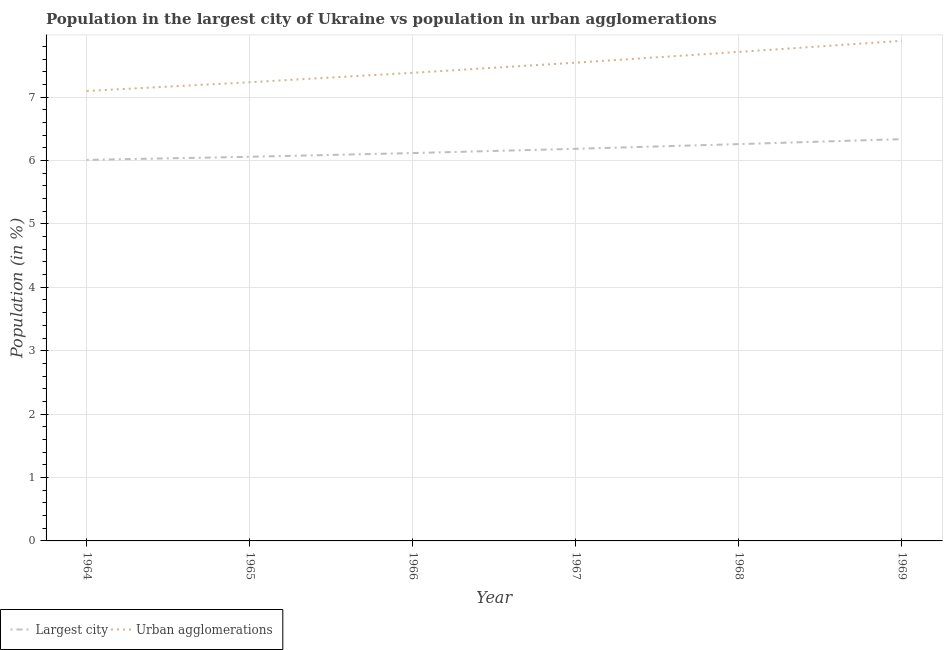How many different coloured lines are there?
Provide a short and direct response. 2. Is the number of lines equal to the number of legend labels?
Your response must be concise. Yes. What is the population in the largest city in 1968?
Your answer should be compact. 6.26. Across all years, what is the maximum population in the largest city?
Offer a very short reply. 6.34. Across all years, what is the minimum population in urban agglomerations?
Your answer should be compact. 7.1. In which year was the population in the largest city maximum?
Make the answer very short. 1969. In which year was the population in urban agglomerations minimum?
Provide a succinct answer. 1964. What is the total population in the largest city in the graph?
Provide a short and direct response. 36.96. What is the difference between the population in urban agglomerations in 1965 and that in 1968?
Provide a short and direct response. -0.48. What is the difference between the population in urban agglomerations in 1966 and the population in the largest city in 1964?
Keep it short and to the point. 1.37. What is the average population in the largest city per year?
Offer a terse response. 6.16. In the year 1964, what is the difference between the population in the largest city and population in urban agglomerations?
Offer a terse response. -1.09. What is the ratio of the population in the largest city in 1966 to that in 1968?
Provide a succinct answer. 0.98. Is the population in urban agglomerations in 1964 less than that in 1967?
Give a very brief answer. Yes. Is the difference between the population in urban agglomerations in 1966 and 1968 greater than the difference between the population in the largest city in 1966 and 1968?
Your response must be concise. No. What is the difference between the highest and the second highest population in the largest city?
Make the answer very short. 0.08. What is the difference between the highest and the lowest population in urban agglomerations?
Give a very brief answer. 0.79. In how many years, is the population in the largest city greater than the average population in the largest city taken over all years?
Provide a succinct answer. 3. Is the population in the largest city strictly greater than the population in urban agglomerations over the years?
Your answer should be very brief. No. How many lines are there?
Offer a terse response. 2. Are the values on the major ticks of Y-axis written in scientific E-notation?
Your answer should be very brief. No. Does the graph contain grids?
Provide a succinct answer. Yes. Where does the legend appear in the graph?
Offer a terse response. Bottom left. How many legend labels are there?
Make the answer very short. 2. What is the title of the graph?
Your answer should be very brief. Population in the largest city of Ukraine vs population in urban agglomerations. What is the Population (in %) in Largest city in 1964?
Offer a terse response. 6.01. What is the Population (in %) of Urban agglomerations in 1964?
Your answer should be very brief. 7.1. What is the Population (in %) of Largest city in 1965?
Provide a short and direct response. 6.06. What is the Population (in %) in Urban agglomerations in 1965?
Provide a short and direct response. 7.23. What is the Population (in %) of Largest city in 1966?
Give a very brief answer. 6.12. What is the Population (in %) of Urban agglomerations in 1966?
Offer a terse response. 7.38. What is the Population (in %) of Largest city in 1967?
Your response must be concise. 6.18. What is the Population (in %) of Urban agglomerations in 1967?
Your answer should be very brief. 7.54. What is the Population (in %) of Largest city in 1968?
Provide a short and direct response. 6.26. What is the Population (in %) in Urban agglomerations in 1968?
Your answer should be very brief. 7.71. What is the Population (in %) of Largest city in 1969?
Provide a short and direct response. 6.34. What is the Population (in %) in Urban agglomerations in 1969?
Your answer should be compact. 7.89. Across all years, what is the maximum Population (in %) in Largest city?
Offer a terse response. 6.34. Across all years, what is the maximum Population (in %) of Urban agglomerations?
Make the answer very short. 7.89. Across all years, what is the minimum Population (in %) in Largest city?
Make the answer very short. 6.01. Across all years, what is the minimum Population (in %) in Urban agglomerations?
Provide a short and direct response. 7.1. What is the total Population (in %) of Largest city in the graph?
Offer a very short reply. 36.96. What is the total Population (in %) of Urban agglomerations in the graph?
Your response must be concise. 44.86. What is the difference between the Population (in %) in Largest city in 1964 and that in 1965?
Give a very brief answer. -0.05. What is the difference between the Population (in %) in Urban agglomerations in 1964 and that in 1965?
Your response must be concise. -0.14. What is the difference between the Population (in %) in Largest city in 1964 and that in 1966?
Your response must be concise. -0.11. What is the difference between the Population (in %) in Urban agglomerations in 1964 and that in 1966?
Your response must be concise. -0.29. What is the difference between the Population (in %) in Largest city in 1964 and that in 1967?
Provide a succinct answer. -0.17. What is the difference between the Population (in %) of Urban agglomerations in 1964 and that in 1967?
Make the answer very short. -0.45. What is the difference between the Population (in %) in Largest city in 1964 and that in 1968?
Give a very brief answer. -0.25. What is the difference between the Population (in %) of Urban agglomerations in 1964 and that in 1968?
Provide a succinct answer. -0.62. What is the difference between the Population (in %) of Largest city in 1964 and that in 1969?
Your answer should be very brief. -0.33. What is the difference between the Population (in %) of Urban agglomerations in 1964 and that in 1969?
Offer a terse response. -0.79. What is the difference between the Population (in %) in Largest city in 1965 and that in 1966?
Offer a terse response. -0.06. What is the difference between the Population (in %) in Urban agglomerations in 1965 and that in 1966?
Offer a very short reply. -0.15. What is the difference between the Population (in %) of Largest city in 1965 and that in 1967?
Provide a short and direct response. -0.13. What is the difference between the Population (in %) in Urban agglomerations in 1965 and that in 1967?
Keep it short and to the point. -0.31. What is the difference between the Population (in %) of Largest city in 1965 and that in 1968?
Provide a short and direct response. -0.2. What is the difference between the Population (in %) in Urban agglomerations in 1965 and that in 1968?
Make the answer very short. -0.48. What is the difference between the Population (in %) in Largest city in 1965 and that in 1969?
Provide a succinct answer. -0.28. What is the difference between the Population (in %) of Urban agglomerations in 1965 and that in 1969?
Make the answer very short. -0.65. What is the difference between the Population (in %) of Largest city in 1966 and that in 1967?
Your answer should be very brief. -0.07. What is the difference between the Population (in %) in Urban agglomerations in 1966 and that in 1967?
Offer a terse response. -0.16. What is the difference between the Population (in %) of Largest city in 1966 and that in 1968?
Provide a succinct answer. -0.14. What is the difference between the Population (in %) of Urban agglomerations in 1966 and that in 1968?
Give a very brief answer. -0.33. What is the difference between the Population (in %) of Largest city in 1966 and that in 1969?
Offer a very short reply. -0.22. What is the difference between the Population (in %) in Urban agglomerations in 1966 and that in 1969?
Offer a terse response. -0.5. What is the difference between the Population (in %) of Largest city in 1967 and that in 1968?
Your answer should be very brief. -0.07. What is the difference between the Population (in %) of Urban agglomerations in 1967 and that in 1968?
Your answer should be very brief. -0.17. What is the difference between the Population (in %) of Largest city in 1967 and that in 1969?
Make the answer very short. -0.15. What is the difference between the Population (in %) of Urban agglomerations in 1967 and that in 1969?
Make the answer very short. -0.34. What is the difference between the Population (in %) of Largest city in 1968 and that in 1969?
Your answer should be very brief. -0.08. What is the difference between the Population (in %) in Urban agglomerations in 1968 and that in 1969?
Make the answer very short. -0.17. What is the difference between the Population (in %) in Largest city in 1964 and the Population (in %) in Urban agglomerations in 1965?
Give a very brief answer. -1.22. What is the difference between the Population (in %) in Largest city in 1964 and the Population (in %) in Urban agglomerations in 1966?
Ensure brevity in your answer.  -1.37. What is the difference between the Population (in %) of Largest city in 1964 and the Population (in %) of Urban agglomerations in 1967?
Your answer should be compact. -1.53. What is the difference between the Population (in %) in Largest city in 1964 and the Population (in %) in Urban agglomerations in 1968?
Your response must be concise. -1.7. What is the difference between the Population (in %) in Largest city in 1964 and the Population (in %) in Urban agglomerations in 1969?
Offer a terse response. -1.88. What is the difference between the Population (in %) in Largest city in 1965 and the Population (in %) in Urban agglomerations in 1966?
Your answer should be very brief. -1.32. What is the difference between the Population (in %) in Largest city in 1965 and the Population (in %) in Urban agglomerations in 1967?
Provide a succinct answer. -1.48. What is the difference between the Population (in %) of Largest city in 1965 and the Population (in %) of Urban agglomerations in 1968?
Offer a very short reply. -1.65. What is the difference between the Population (in %) of Largest city in 1965 and the Population (in %) of Urban agglomerations in 1969?
Provide a short and direct response. -1.83. What is the difference between the Population (in %) in Largest city in 1966 and the Population (in %) in Urban agglomerations in 1967?
Keep it short and to the point. -1.43. What is the difference between the Population (in %) in Largest city in 1966 and the Population (in %) in Urban agglomerations in 1968?
Provide a short and direct response. -1.6. What is the difference between the Population (in %) of Largest city in 1966 and the Population (in %) of Urban agglomerations in 1969?
Provide a short and direct response. -1.77. What is the difference between the Population (in %) of Largest city in 1967 and the Population (in %) of Urban agglomerations in 1968?
Offer a terse response. -1.53. What is the difference between the Population (in %) of Largest city in 1967 and the Population (in %) of Urban agglomerations in 1969?
Keep it short and to the point. -1.7. What is the difference between the Population (in %) of Largest city in 1968 and the Population (in %) of Urban agglomerations in 1969?
Your answer should be compact. -1.63. What is the average Population (in %) of Largest city per year?
Your answer should be compact. 6.16. What is the average Population (in %) in Urban agglomerations per year?
Offer a very short reply. 7.48. In the year 1964, what is the difference between the Population (in %) in Largest city and Population (in %) in Urban agglomerations?
Your response must be concise. -1.09. In the year 1965, what is the difference between the Population (in %) in Largest city and Population (in %) in Urban agglomerations?
Make the answer very short. -1.18. In the year 1966, what is the difference between the Population (in %) in Largest city and Population (in %) in Urban agglomerations?
Make the answer very short. -1.27. In the year 1967, what is the difference between the Population (in %) of Largest city and Population (in %) of Urban agglomerations?
Your response must be concise. -1.36. In the year 1968, what is the difference between the Population (in %) in Largest city and Population (in %) in Urban agglomerations?
Offer a very short reply. -1.45. In the year 1969, what is the difference between the Population (in %) in Largest city and Population (in %) in Urban agglomerations?
Your answer should be very brief. -1.55. What is the ratio of the Population (in %) of Urban agglomerations in 1964 to that in 1965?
Offer a terse response. 0.98. What is the ratio of the Population (in %) of Largest city in 1964 to that in 1966?
Give a very brief answer. 0.98. What is the ratio of the Population (in %) in Urban agglomerations in 1964 to that in 1966?
Offer a very short reply. 0.96. What is the ratio of the Population (in %) in Largest city in 1964 to that in 1967?
Keep it short and to the point. 0.97. What is the ratio of the Population (in %) of Urban agglomerations in 1964 to that in 1967?
Your answer should be compact. 0.94. What is the ratio of the Population (in %) of Largest city in 1964 to that in 1968?
Provide a succinct answer. 0.96. What is the ratio of the Population (in %) in Urban agglomerations in 1964 to that in 1968?
Your answer should be compact. 0.92. What is the ratio of the Population (in %) in Largest city in 1964 to that in 1969?
Provide a succinct answer. 0.95. What is the ratio of the Population (in %) of Urban agglomerations in 1964 to that in 1969?
Your answer should be very brief. 0.9. What is the ratio of the Population (in %) of Urban agglomerations in 1965 to that in 1966?
Keep it short and to the point. 0.98. What is the ratio of the Population (in %) of Largest city in 1965 to that in 1967?
Your response must be concise. 0.98. What is the ratio of the Population (in %) in Largest city in 1965 to that in 1968?
Your answer should be very brief. 0.97. What is the ratio of the Population (in %) of Urban agglomerations in 1965 to that in 1968?
Give a very brief answer. 0.94. What is the ratio of the Population (in %) in Largest city in 1965 to that in 1969?
Make the answer very short. 0.96. What is the ratio of the Population (in %) of Urban agglomerations in 1965 to that in 1969?
Provide a succinct answer. 0.92. What is the ratio of the Population (in %) in Urban agglomerations in 1966 to that in 1967?
Make the answer very short. 0.98. What is the ratio of the Population (in %) in Largest city in 1966 to that in 1968?
Offer a very short reply. 0.98. What is the ratio of the Population (in %) of Urban agglomerations in 1966 to that in 1968?
Provide a succinct answer. 0.96. What is the ratio of the Population (in %) in Largest city in 1966 to that in 1969?
Offer a terse response. 0.97. What is the ratio of the Population (in %) of Urban agglomerations in 1966 to that in 1969?
Keep it short and to the point. 0.94. What is the ratio of the Population (in %) of Largest city in 1967 to that in 1968?
Give a very brief answer. 0.99. What is the ratio of the Population (in %) of Urban agglomerations in 1967 to that in 1968?
Ensure brevity in your answer.  0.98. What is the ratio of the Population (in %) of Largest city in 1967 to that in 1969?
Your answer should be very brief. 0.98. What is the ratio of the Population (in %) of Urban agglomerations in 1967 to that in 1969?
Your response must be concise. 0.96. What is the ratio of the Population (in %) in Largest city in 1968 to that in 1969?
Offer a terse response. 0.99. What is the ratio of the Population (in %) of Urban agglomerations in 1968 to that in 1969?
Give a very brief answer. 0.98. What is the difference between the highest and the second highest Population (in %) in Largest city?
Keep it short and to the point. 0.08. What is the difference between the highest and the second highest Population (in %) of Urban agglomerations?
Give a very brief answer. 0.17. What is the difference between the highest and the lowest Population (in %) in Largest city?
Offer a very short reply. 0.33. What is the difference between the highest and the lowest Population (in %) in Urban agglomerations?
Make the answer very short. 0.79. 